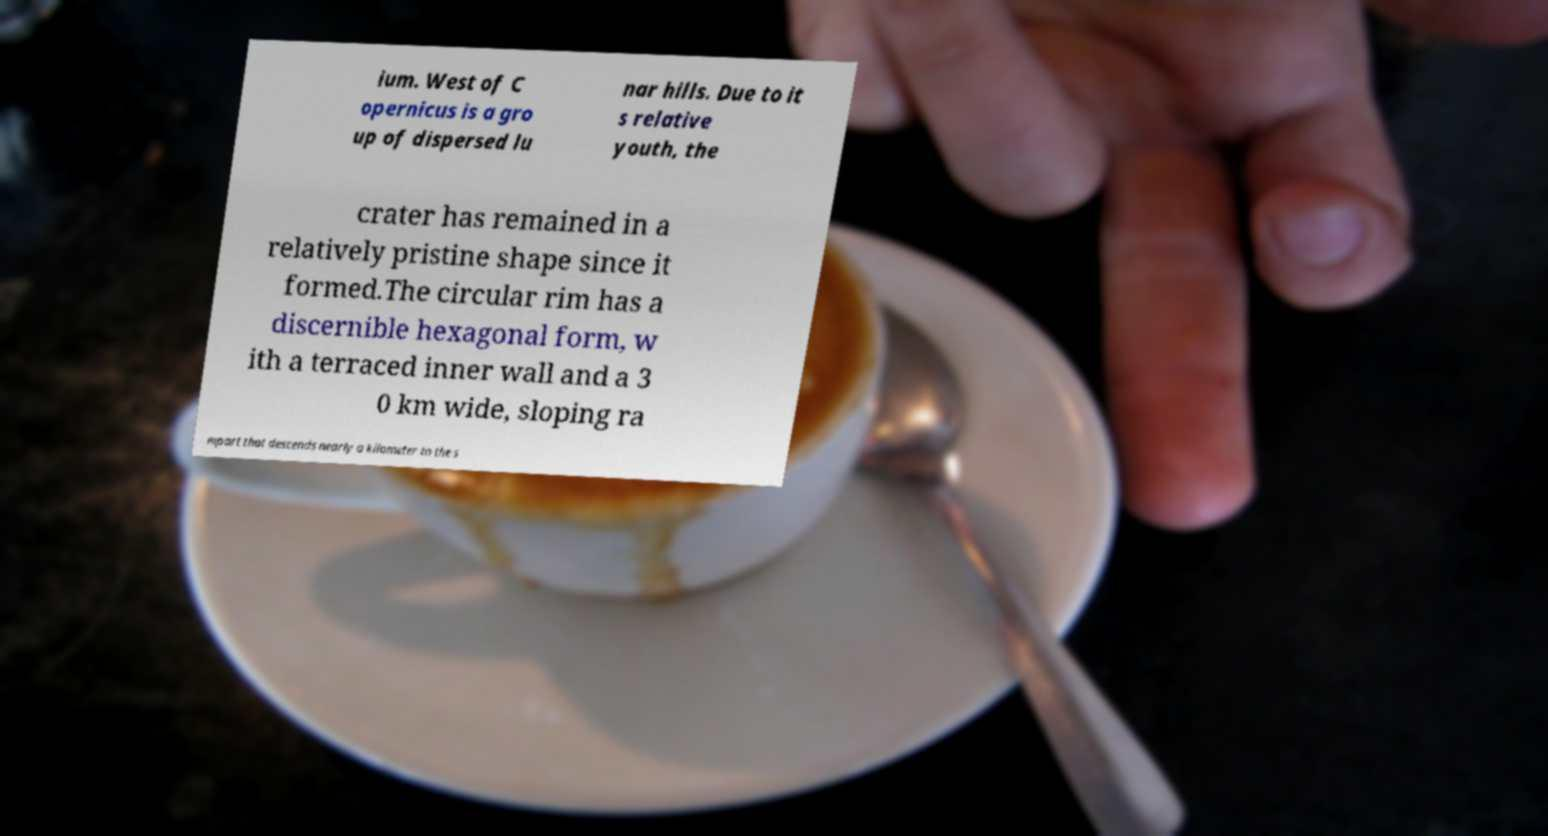Could you extract and type out the text from this image? ium. West of C opernicus is a gro up of dispersed lu nar hills. Due to it s relative youth, the crater has remained in a relatively pristine shape since it formed.The circular rim has a discernible hexagonal form, w ith a terraced inner wall and a 3 0 km wide, sloping ra mpart that descends nearly a kilometer to the s 